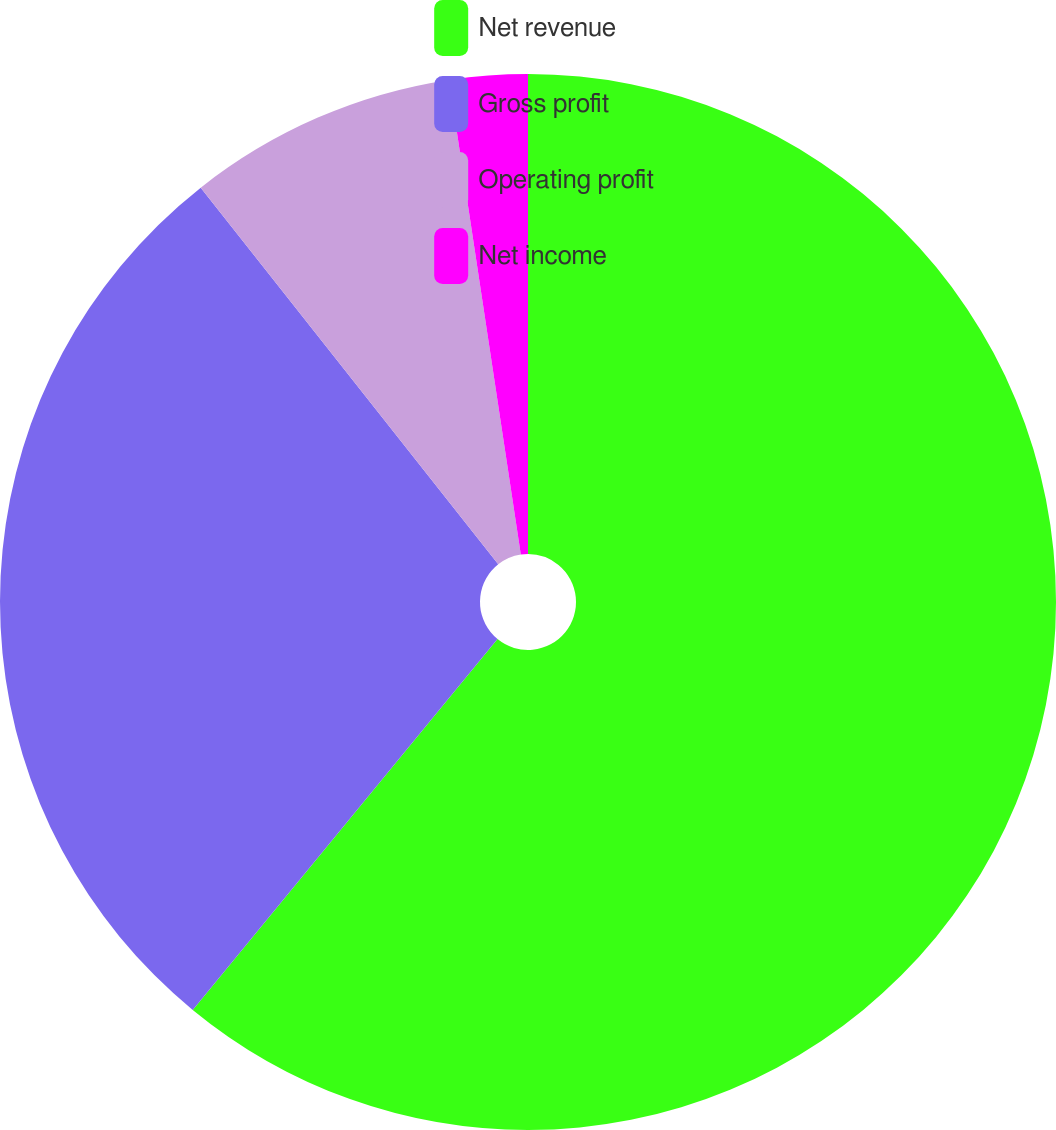<chart> <loc_0><loc_0><loc_500><loc_500><pie_chart><fcel>Net revenue<fcel>Gross profit<fcel>Operating profit<fcel>Net income<nl><fcel>60.95%<fcel>28.41%<fcel>8.25%<fcel>2.39%<nl></chart> 